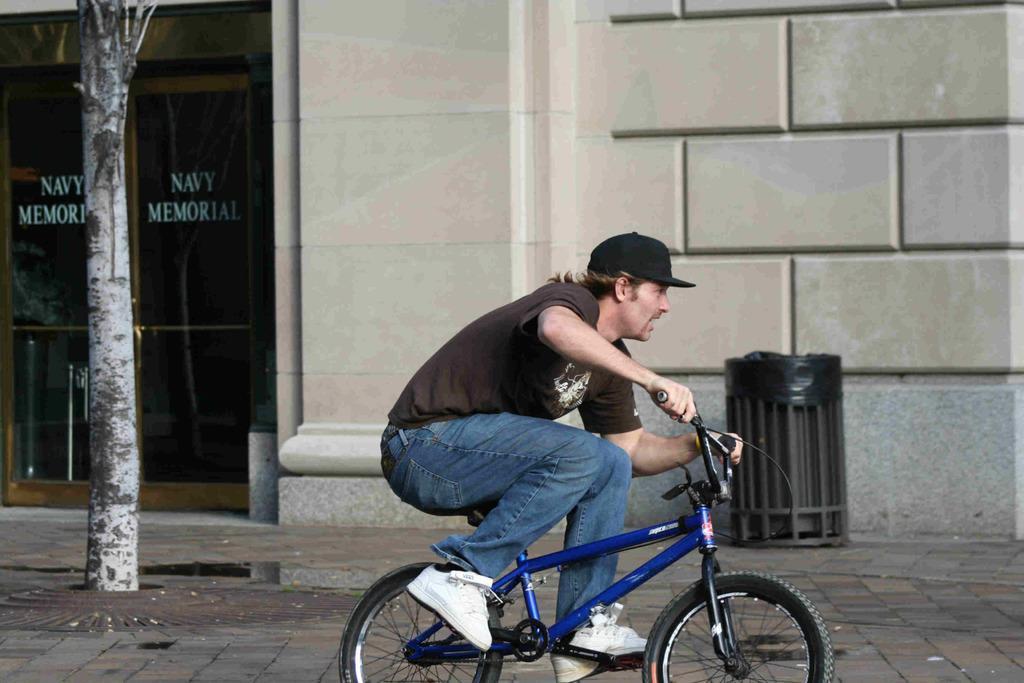Please provide a concise description of this image. It is a footpath, there is a man who is riding a cycle , there is a dustbin to the left side of the dustbin there is a door in the background there is a marble wall. 